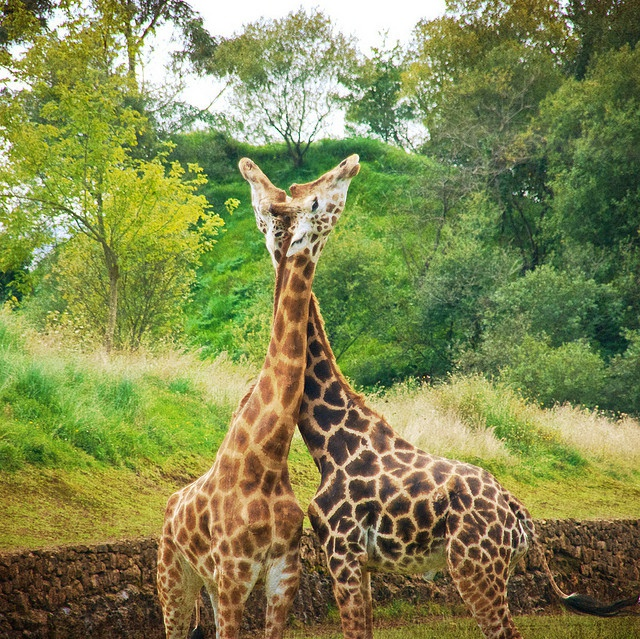Describe the objects in this image and their specific colors. I can see giraffe in lightgreen, black, maroon, and gray tones and giraffe in lightgreen, tan, brown, maroon, and gray tones in this image. 